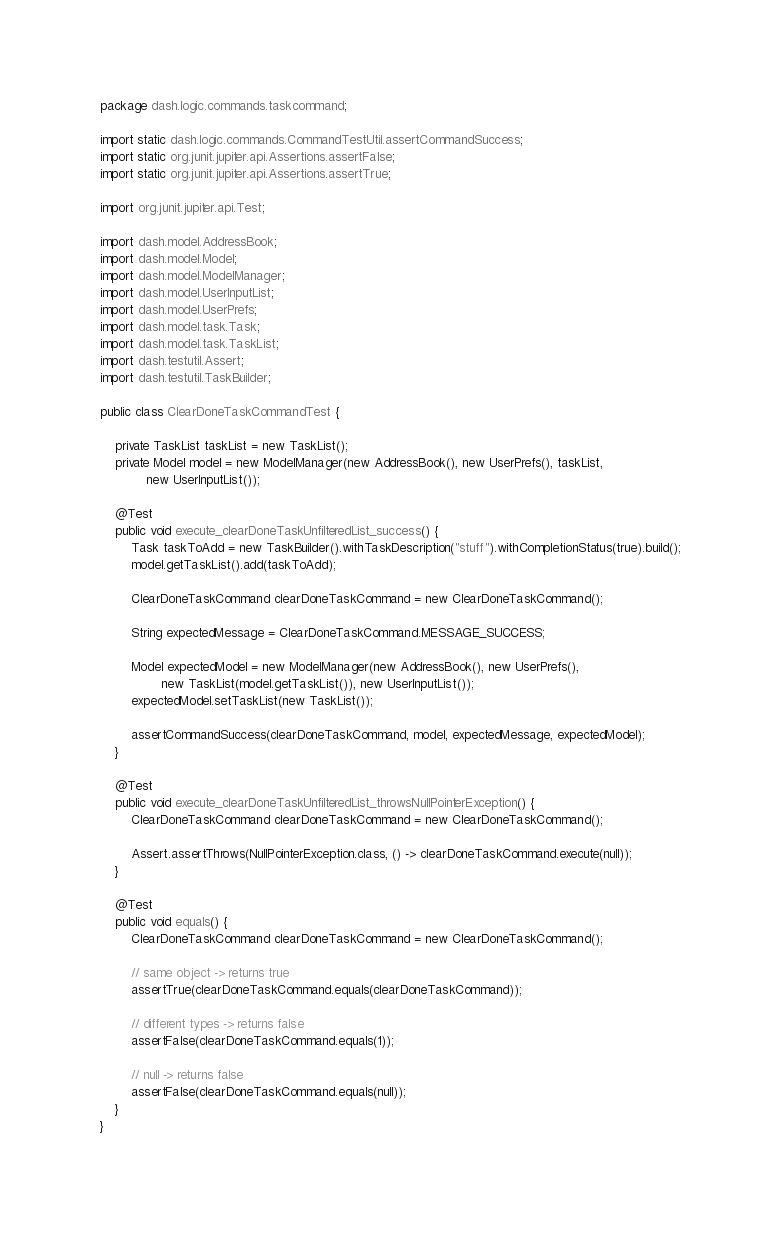<code> <loc_0><loc_0><loc_500><loc_500><_Java_>package dash.logic.commands.taskcommand;

import static dash.logic.commands.CommandTestUtil.assertCommandSuccess;
import static org.junit.jupiter.api.Assertions.assertFalse;
import static org.junit.jupiter.api.Assertions.assertTrue;

import org.junit.jupiter.api.Test;

import dash.model.AddressBook;
import dash.model.Model;
import dash.model.ModelManager;
import dash.model.UserInputList;
import dash.model.UserPrefs;
import dash.model.task.Task;
import dash.model.task.TaskList;
import dash.testutil.Assert;
import dash.testutil.TaskBuilder;

public class ClearDoneTaskCommandTest {

    private TaskList taskList = new TaskList();
    private Model model = new ModelManager(new AddressBook(), new UserPrefs(), taskList,
            new UserInputList());

    @Test
    public void execute_clearDoneTaskUnfilteredList_success() {
        Task taskToAdd = new TaskBuilder().withTaskDescription("stuff").withCompletionStatus(true).build();
        model.getTaskList().add(taskToAdd);

        ClearDoneTaskCommand clearDoneTaskCommand = new ClearDoneTaskCommand();

        String expectedMessage = ClearDoneTaskCommand.MESSAGE_SUCCESS;

        Model expectedModel = new ModelManager(new AddressBook(), new UserPrefs(),
                new TaskList(model.getTaskList()), new UserInputList());
        expectedModel.setTaskList(new TaskList());

        assertCommandSuccess(clearDoneTaskCommand, model, expectedMessage, expectedModel);
    }

    @Test
    public void execute_clearDoneTaskUnfilteredList_throwsNullPointerException() {
        ClearDoneTaskCommand clearDoneTaskCommand = new ClearDoneTaskCommand();

        Assert.assertThrows(NullPointerException.class, () -> clearDoneTaskCommand.execute(null));
    }

    @Test
    public void equals() {
        ClearDoneTaskCommand clearDoneTaskCommand = new ClearDoneTaskCommand();

        // same object -> returns true
        assertTrue(clearDoneTaskCommand.equals(clearDoneTaskCommand));

        // different types -> returns false
        assertFalse(clearDoneTaskCommand.equals(1));

        // null -> returns false
        assertFalse(clearDoneTaskCommand.equals(null));
    }
}
</code> 